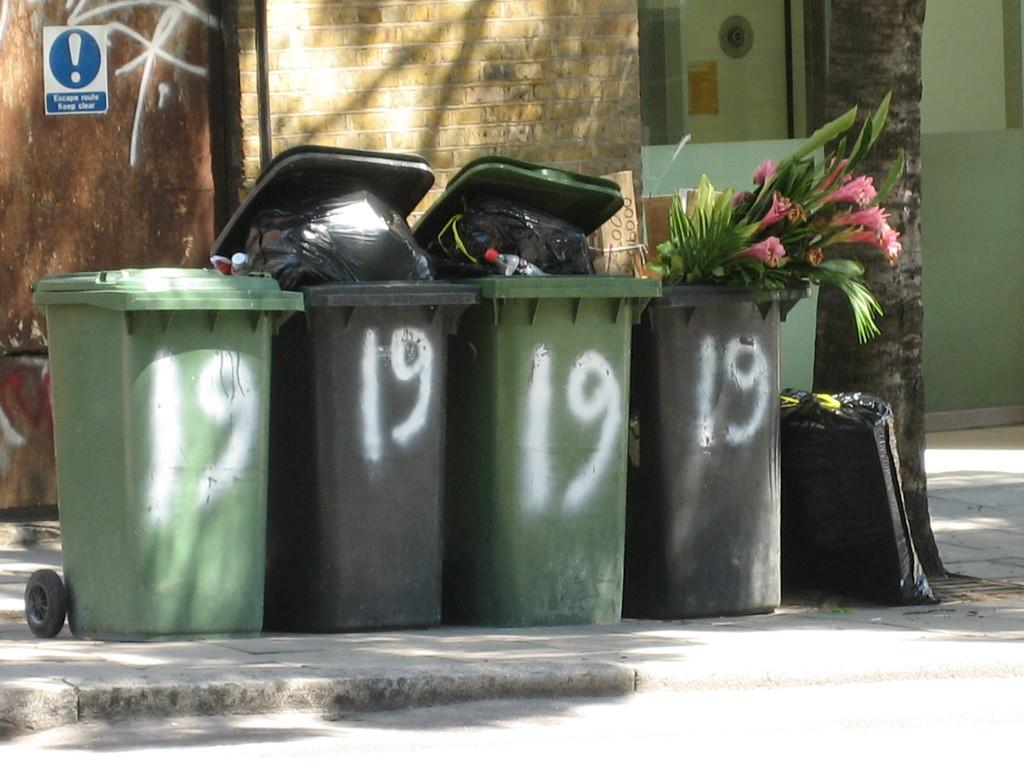<image>
Write a terse but informative summary of the picture. Several garbage cans with then number 19 painted on them are lined up on a curb. 